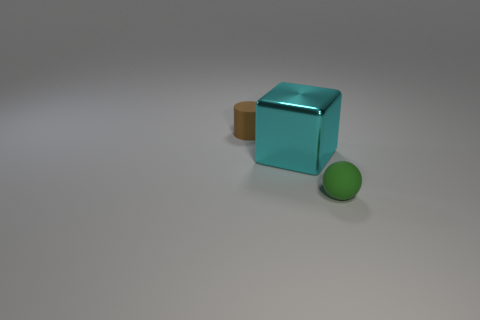Add 2 purple rubber cylinders. How many objects exist? 5 Subtract 0 purple spheres. How many objects are left? 3 Subtract all cylinders. How many objects are left? 2 Subtract 1 cylinders. How many cylinders are left? 0 Subtract all brown blocks. Subtract all gray balls. How many blocks are left? 1 Subtract all green balls. How many yellow cylinders are left? 0 Subtract all tiny green balls. Subtract all big gray matte objects. How many objects are left? 2 Add 3 green things. How many green things are left? 4 Add 3 small green objects. How many small green objects exist? 4 